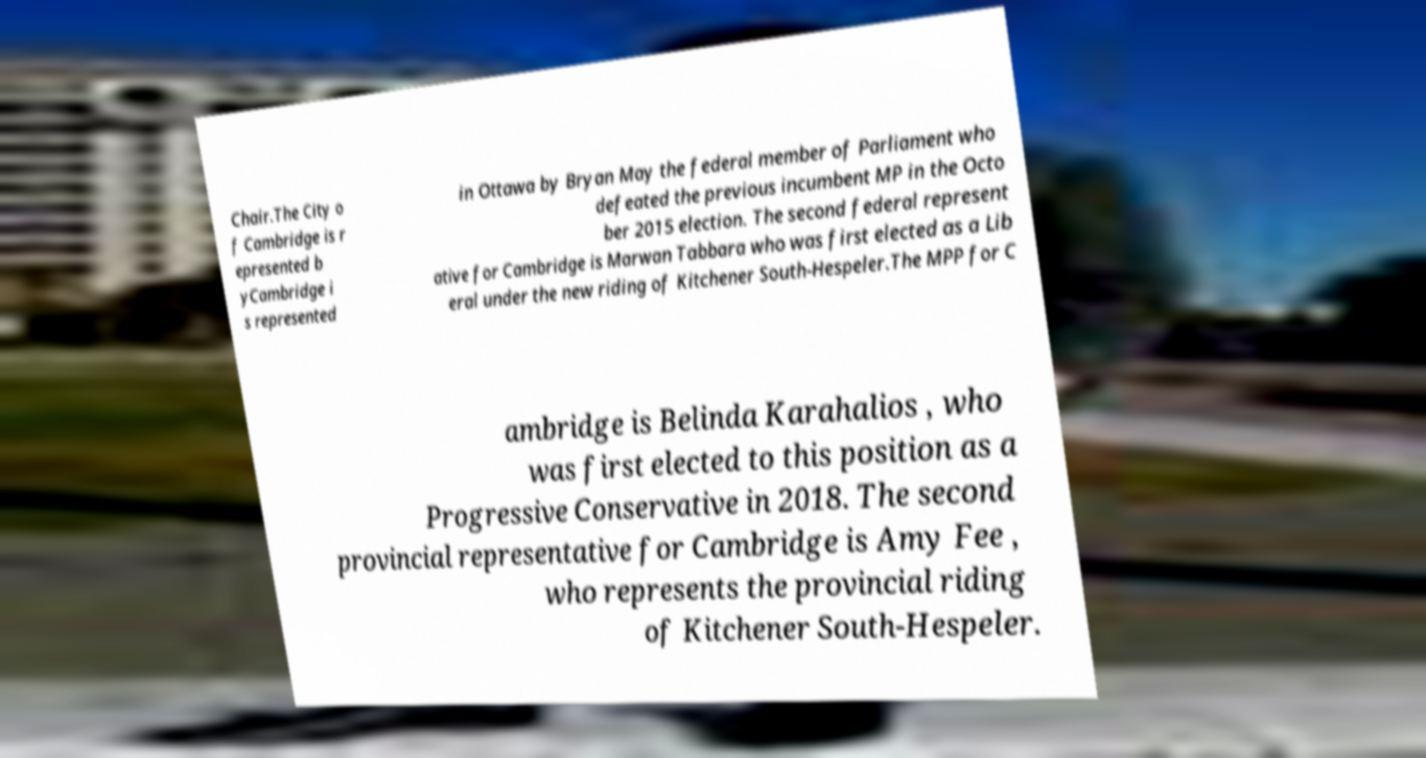Can you read and provide the text displayed in the image?This photo seems to have some interesting text. Can you extract and type it out for me? Chair.The City o f Cambridge is r epresented b yCambridge i s represented in Ottawa by Bryan May the federal member of Parliament who defeated the previous incumbent MP in the Octo ber 2015 election. The second federal represent ative for Cambridge is Marwan Tabbara who was first elected as a Lib eral under the new riding of Kitchener South-Hespeler.The MPP for C ambridge is Belinda Karahalios , who was first elected to this position as a Progressive Conservative in 2018. The second provincial representative for Cambridge is Amy Fee , who represents the provincial riding of Kitchener South-Hespeler. 